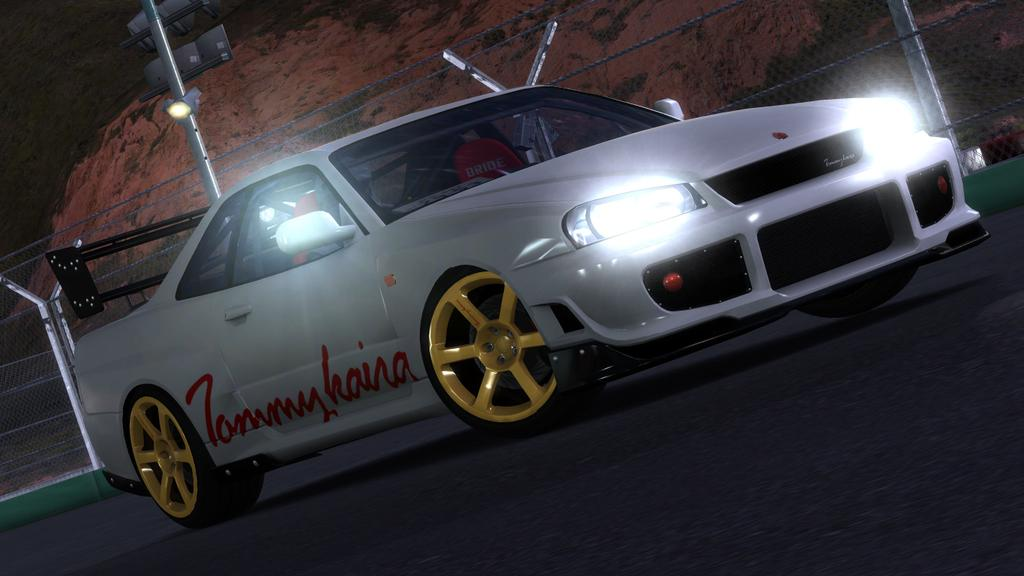What type of vehicle is in the image? There is a white car in the image. What is at the bottom of the image? There is a road at the bottom of the image. What can be seen in the distance in the image? There is a mountain in the background of the image. What is present along the road in the image? There is fencing, a pole, and lights in the image. What type of health benefits can be gained from the rock in the image? There is no rock present in the image; it features a white car, a road, a mountain in the background, and fencing, a pole, and lights along the road. 